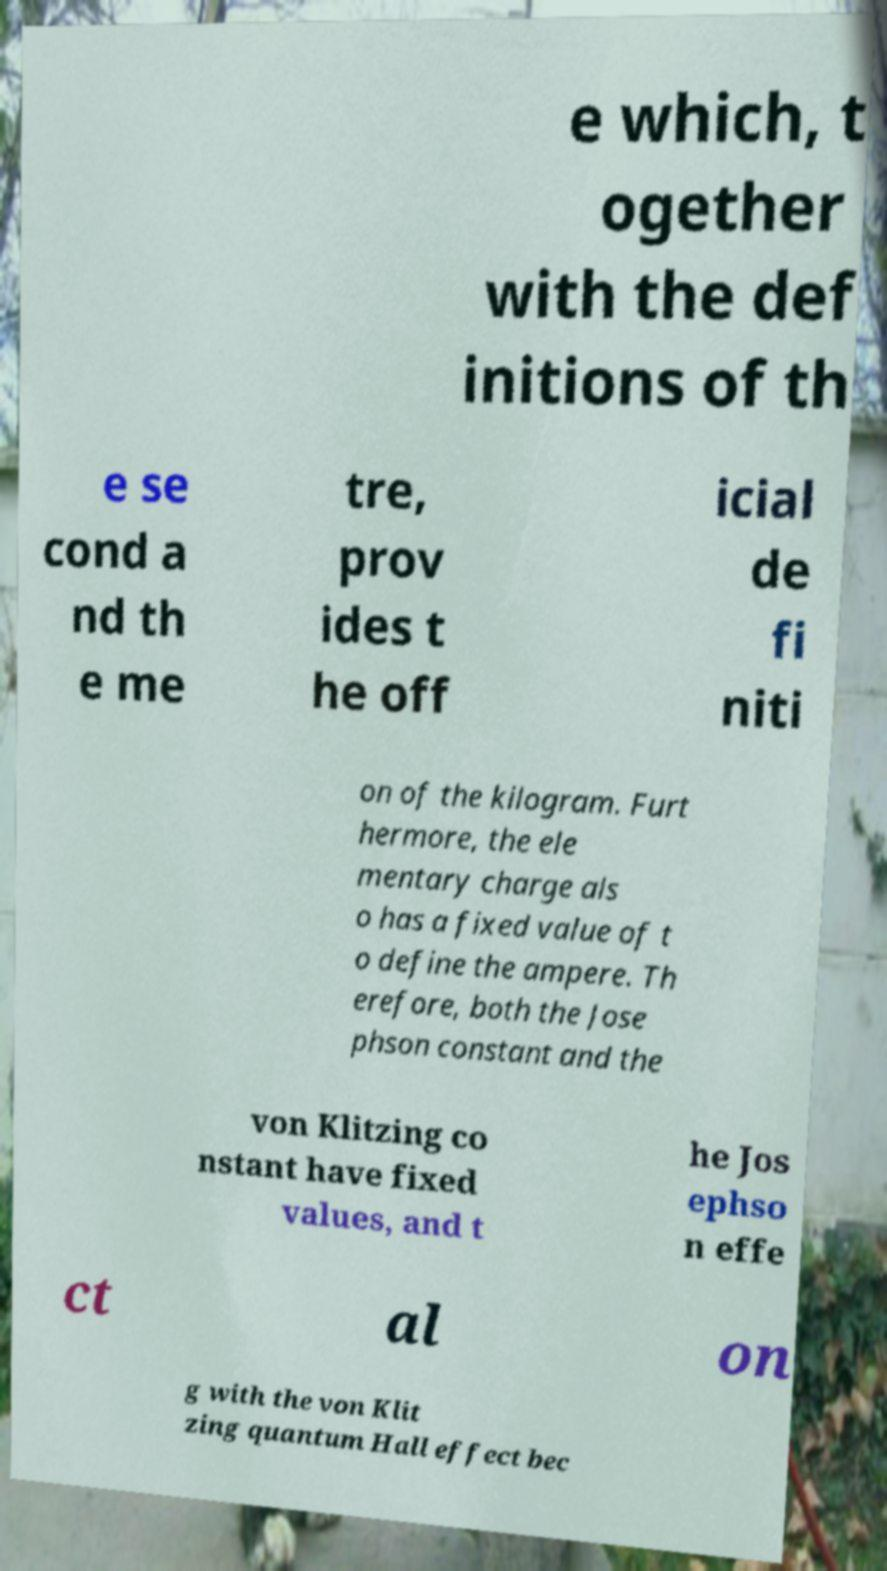Please read and relay the text visible in this image. What does it say? e which, t ogether with the def initions of th e se cond a nd th e me tre, prov ides t he off icial de fi niti on of the kilogram. Furt hermore, the ele mentary charge als o has a fixed value of t o define the ampere. Th erefore, both the Jose phson constant and the von Klitzing co nstant have fixed values, and t he Jos ephso n effe ct al on g with the von Klit zing quantum Hall effect bec 